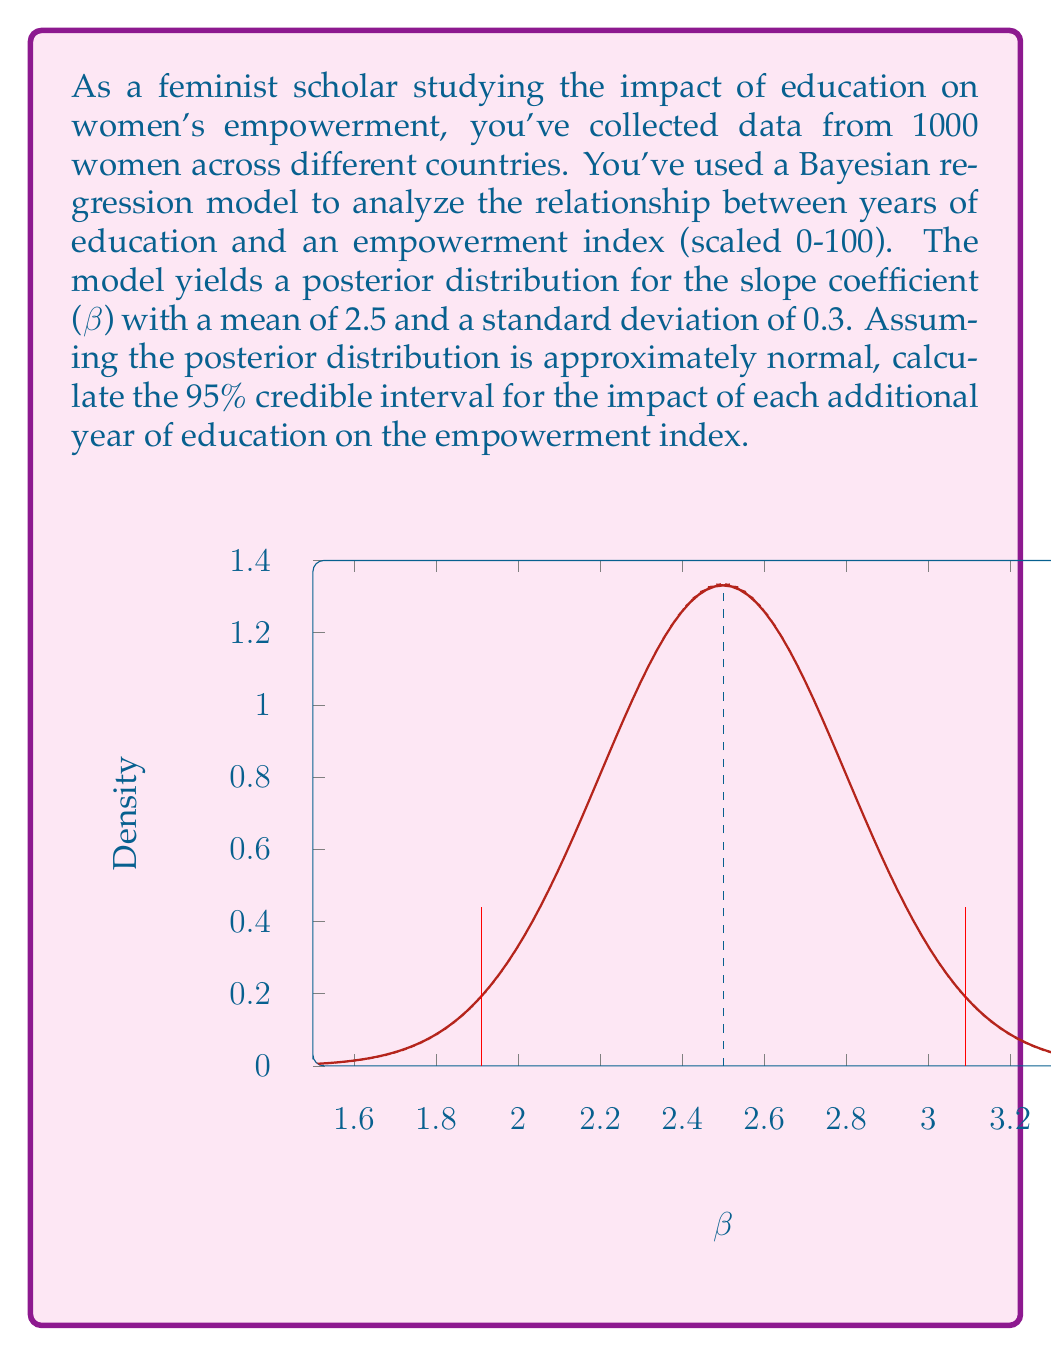Teach me how to tackle this problem. To calculate the 95% credible interval for a normally distributed posterior, we need to find the values that encompass the middle 95% of the distribution. This can be done using the following steps:

1. Recall that for a normal distribution, approximately 95% of the data falls within 1.96 standard deviations of the mean.

2. The posterior distribution has a mean $\mu = 2.5$ and standard deviation $\sigma = 0.3$.

3. Calculate the lower bound of the credible interval:
   $\text{Lower Bound} = \mu - 1.96\sigma = 2.5 - 1.96(0.3) = 1.912$

4. Calculate the upper bound of the credible interval:
   $\text{Upper Bound} = \mu + 1.96\sigma = 2.5 + 1.96(0.3) = 3.088$

5. Round the results to two decimal places for practicality.

Therefore, we can be 95% confident that the true impact of each additional year of education on the empowerment index lies between 1.91 and 3.09 points.

Interpretation: With 95% probability, each additional year of education is associated with an increase in the empowerment index between 1.91 and 3.09 points, holding other factors constant.
Answer: 95% Credible Interval: [1.91, 3.09] 